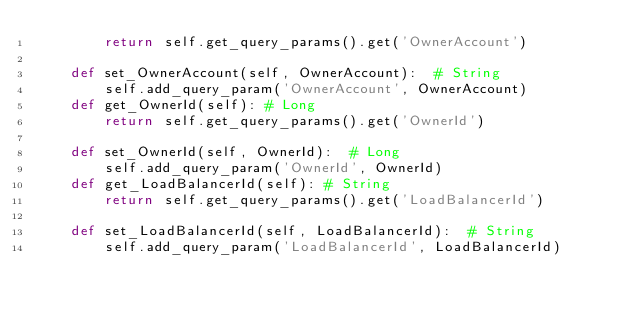Convert code to text. <code><loc_0><loc_0><loc_500><loc_500><_Python_>		return self.get_query_params().get('OwnerAccount')

	def set_OwnerAccount(self, OwnerAccount):  # String
		self.add_query_param('OwnerAccount', OwnerAccount)
	def get_OwnerId(self): # Long
		return self.get_query_params().get('OwnerId')

	def set_OwnerId(self, OwnerId):  # Long
		self.add_query_param('OwnerId', OwnerId)
	def get_LoadBalancerId(self): # String
		return self.get_query_params().get('LoadBalancerId')

	def set_LoadBalancerId(self, LoadBalancerId):  # String
		self.add_query_param('LoadBalancerId', LoadBalancerId)
</code> 